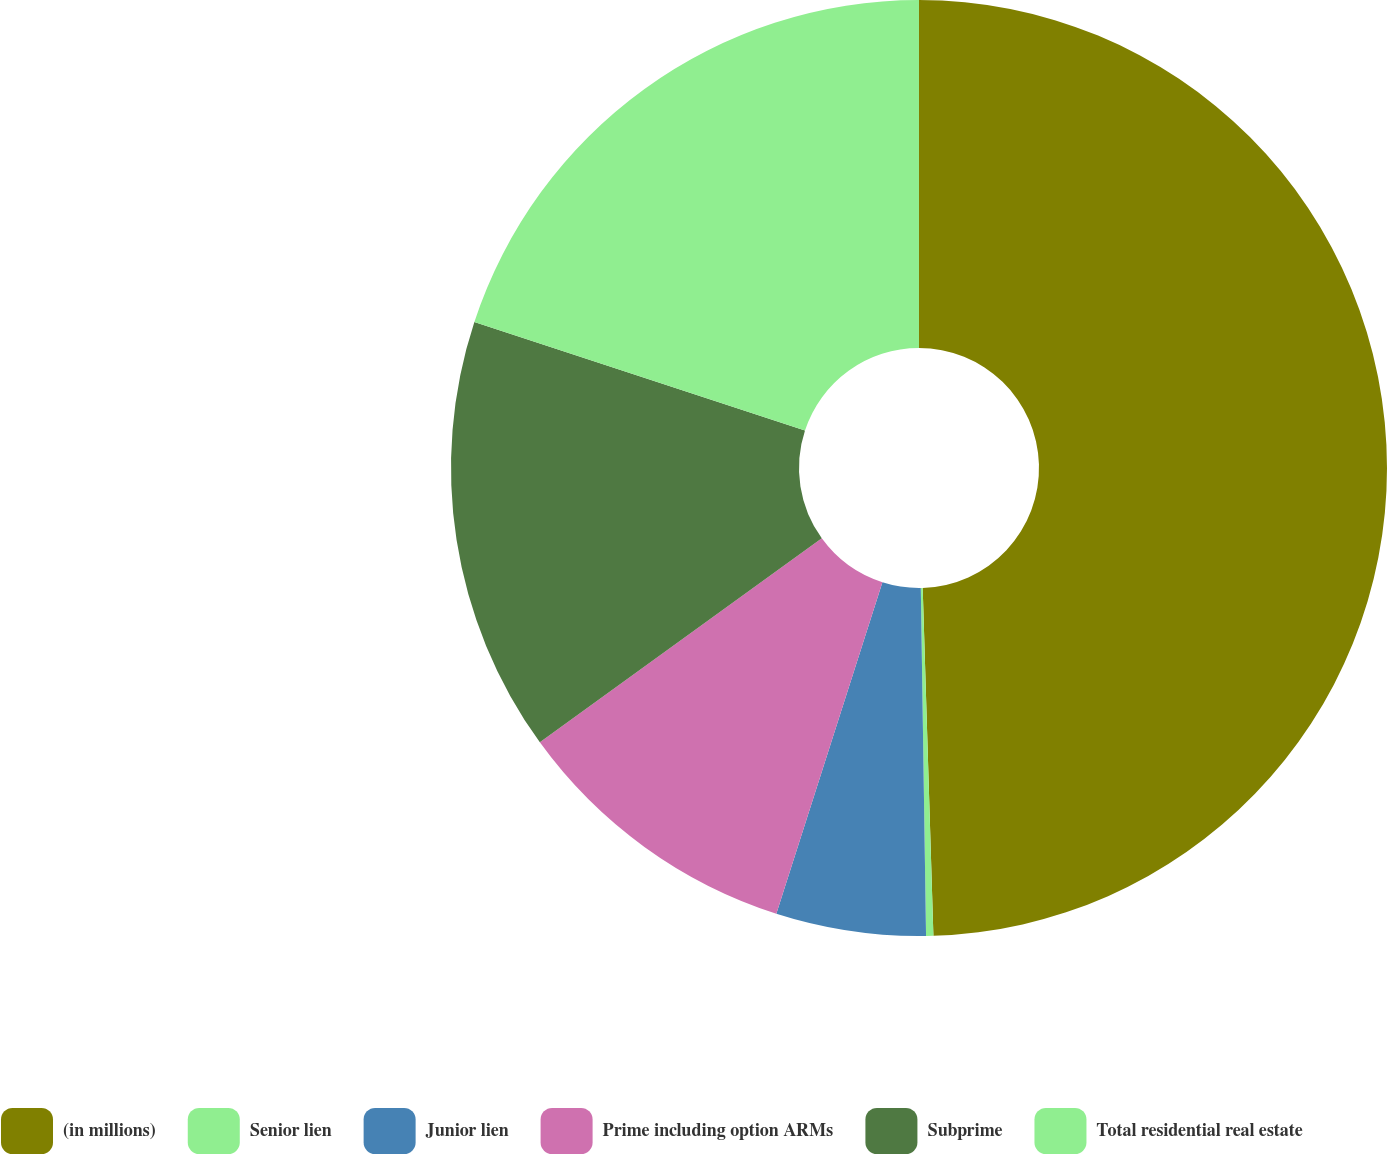Convert chart. <chart><loc_0><loc_0><loc_500><loc_500><pie_chart><fcel>(in millions)<fcel>Senior lien<fcel>Junior lien<fcel>Prime including option ARMs<fcel>Subprime<fcel>Total residential real estate<nl><fcel>49.51%<fcel>0.25%<fcel>5.17%<fcel>10.1%<fcel>15.02%<fcel>19.95%<nl></chart> 